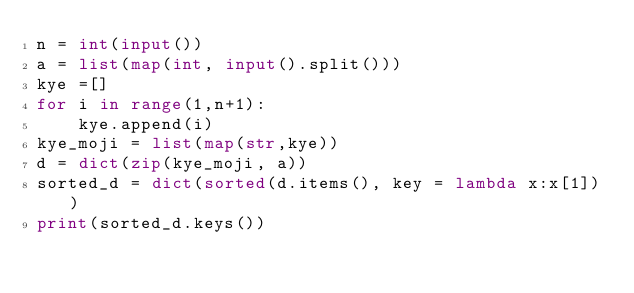Convert code to text. <code><loc_0><loc_0><loc_500><loc_500><_Python_>n = int(input())
a = list(map(int, input().split()))
kye =[]
for i in range(1,n+1):
    kye.append(i)
kye_moji = list(map(str,kye))
d = dict(zip(kye_moji, a)) 
sorted_d = dict(sorted(d.items(), key = lambda x:x[1]))
print(sorted_d.keys())</code> 